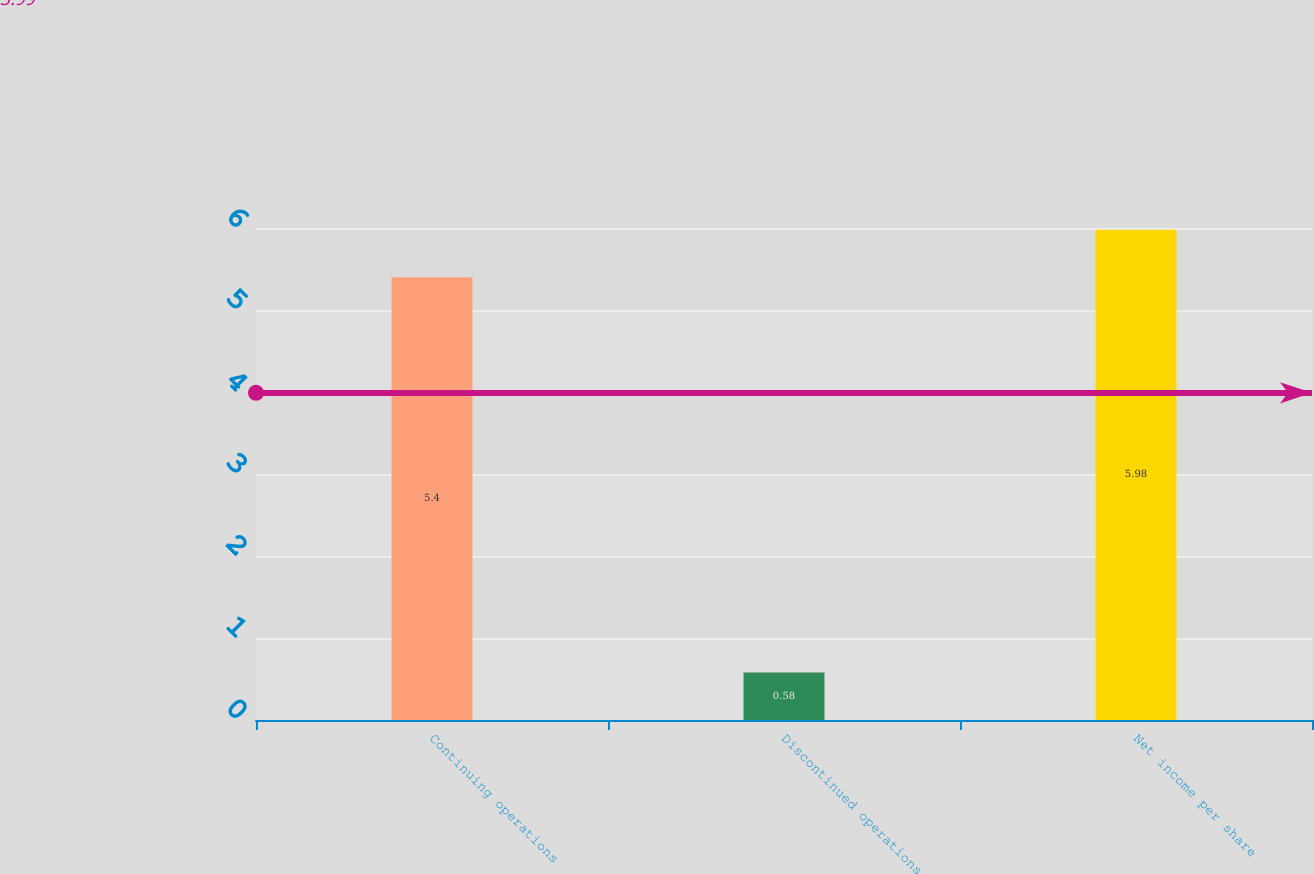Convert chart to OTSL. <chart><loc_0><loc_0><loc_500><loc_500><bar_chart><fcel>Continuing operations<fcel>Discontinued operations<fcel>Net income per share<nl><fcel>5.4<fcel>0.58<fcel>5.98<nl></chart> 